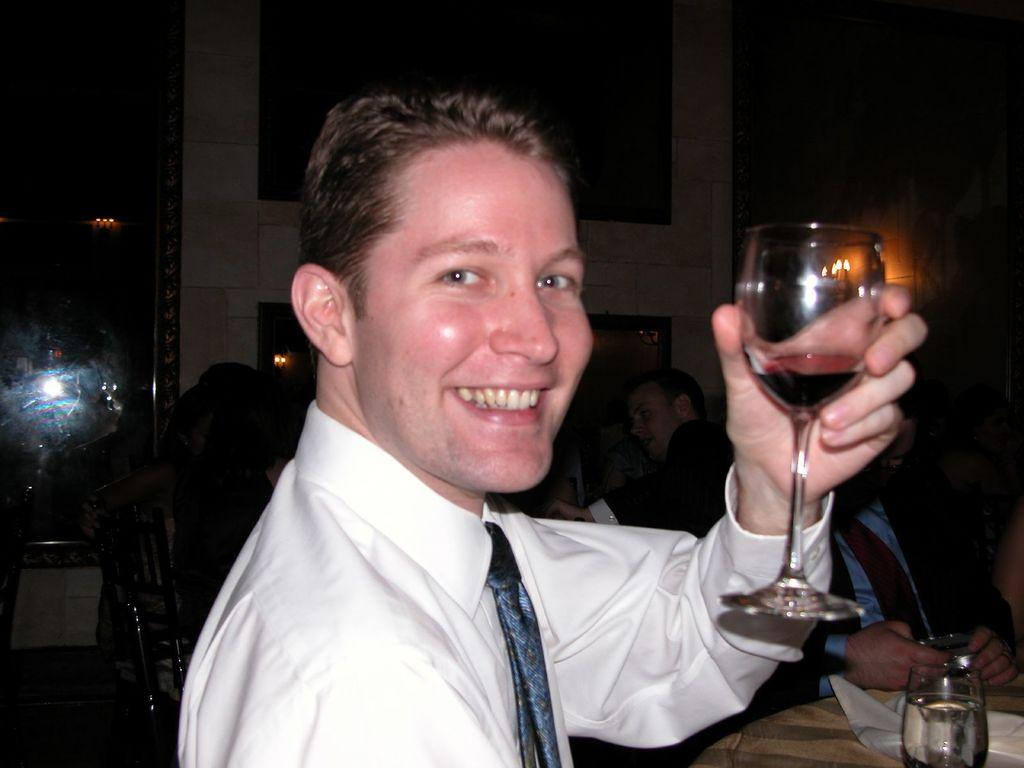Who is present in the image? There is a man in the image. What is the man doing in the image? The man is smiling and holding a glass in his hand. What can be seen in the background of the image? There are people sitting and a table in the background of the image. Is there anything else on the table in the background? Yes, there is a glass on the table in the background. What type of tomatoes can be seen growing in the image? There are no tomatoes present in the image. Can you tell me how the guide is helping the man in the image? There is no guide present in the image, and the man is not receiving any assistance. 